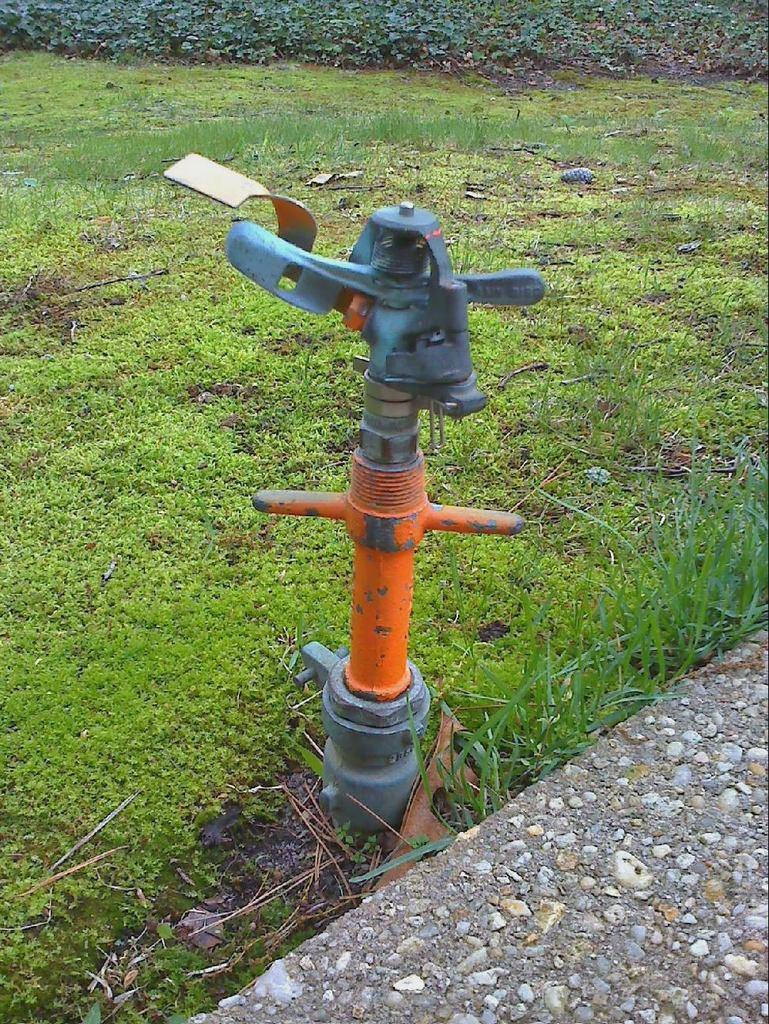What can be seen in the image that is related to water or plumbing? There is a water pipe in the image. What type of vegetation is visible in the image? There is grass visible in the image. How many prisoners can be seen in the image? There are no prisoners present in the image; it features a water pipe and grass. What type of cracker is being used to break the water pipe in the image? There is no cracker or any object being used to break the water pipe in the image; it is simply a water pipe and grass. 